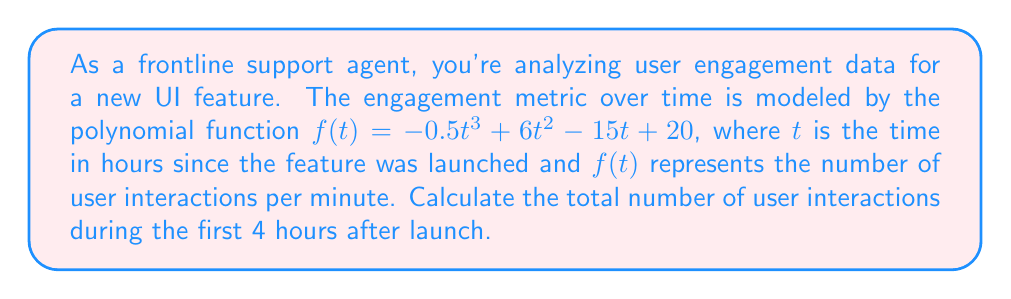Give your solution to this math problem. To find the total number of user interactions during the first 4 hours, we need to calculate the area under the curve of $f(t)$ from $t=0$ to $t=4$. This can be done using definite integration:

1) Set up the definite integral:
   $$\int_0^4 (-0.5t^3 + 6t^2 - 15t + 20) dt$$

2) Integrate the polynomial term by term:
   $$\left[-\frac{1}{8}t^4 + 2t^3 - \frac{15}{2}t^2 + 20t\right]_0^4$$

3) Evaluate the integral at the upper and lower bounds:
   $$\left(-\frac{1}{8}(4^4) + 2(4^3) - \frac{15}{2}(4^2) + 20(4)\right) - \left(-\frac{1}{8}(0^4) + 2(0^3) - \frac{15}{2}(0^2) + 20(0)\right)$$

4) Simplify:
   $$(-16 + 128 - 120 + 80) - (0)$$
   $$= 72$$

5) The result is in user interactions per minute. To get the total interactions over 4 hours, multiply by 60 minutes/hour and 4 hours:
   $$72 \cdot 60 \cdot 4 = 17,280$$

Therefore, there were 17,280 user interactions during the first 4 hours after launch.
Answer: 17,280 user interactions 